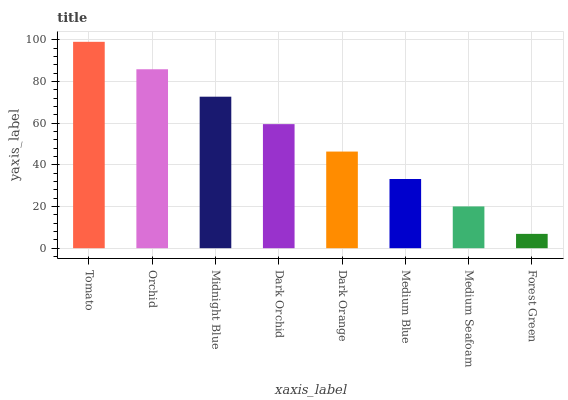Is Forest Green the minimum?
Answer yes or no. Yes. Is Tomato the maximum?
Answer yes or no. Yes. Is Orchid the minimum?
Answer yes or no. No. Is Orchid the maximum?
Answer yes or no. No. Is Tomato greater than Orchid?
Answer yes or no. Yes. Is Orchid less than Tomato?
Answer yes or no. Yes. Is Orchid greater than Tomato?
Answer yes or no. No. Is Tomato less than Orchid?
Answer yes or no. No. Is Dark Orchid the high median?
Answer yes or no. Yes. Is Dark Orange the low median?
Answer yes or no. Yes. Is Dark Orange the high median?
Answer yes or no. No. Is Orchid the low median?
Answer yes or no. No. 